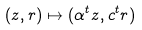Convert formula to latex. <formula><loc_0><loc_0><loc_500><loc_500>( z , r ) \mapsto ( \alpha ^ { t } z , c ^ { t } r )</formula> 